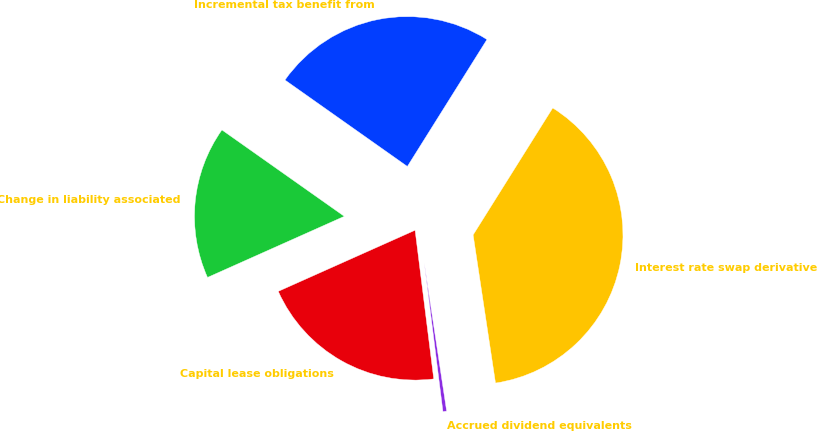<chart> <loc_0><loc_0><loc_500><loc_500><pie_chart><fcel>Incremental tax benefit from<fcel>Change in liability associated<fcel>Capital lease obligations<fcel>Accrued dividend equivalents<fcel>Interest rate swap derivative<nl><fcel>24.13%<fcel>16.47%<fcel>20.3%<fcel>0.4%<fcel>38.7%<nl></chart> 